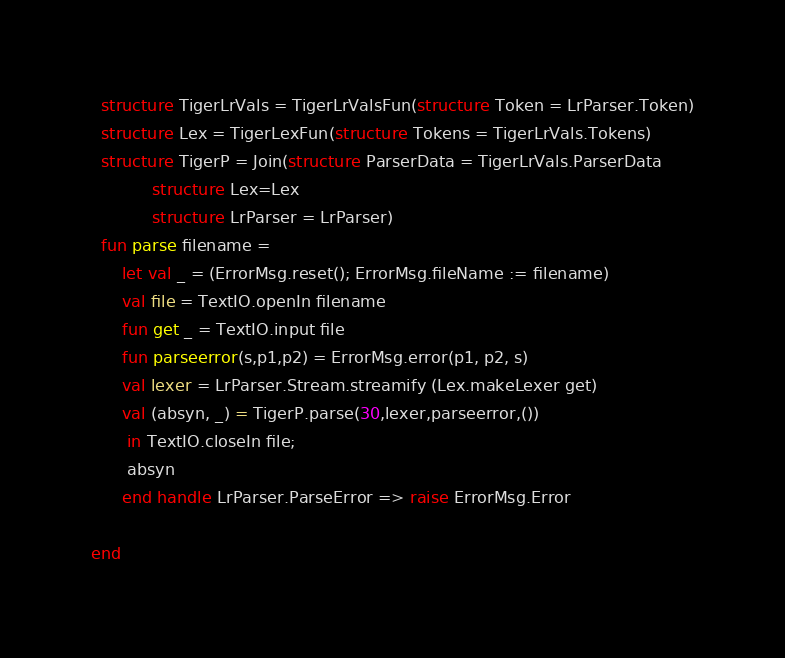Convert code to text. <code><loc_0><loc_0><loc_500><loc_500><_SML_>  structure TigerLrVals = TigerLrValsFun(structure Token = LrParser.Token)
  structure Lex = TigerLexFun(structure Tokens = TigerLrVals.Tokens)
  structure TigerP = Join(structure ParserData = TigerLrVals.ParserData
			structure Lex=Lex
			structure LrParser = LrParser)
  fun parse filename =
      let val _ = (ErrorMsg.reset(); ErrorMsg.fileName := filename)
	  val file = TextIO.openIn filename
	  fun get _ = TextIO.input file
	  fun parseerror(s,p1,p2) = ErrorMsg.error(p1, p2, s)
	  val lexer = LrParser.Stream.streamify (Lex.makeLexer get)
	  val (absyn, _) = TigerP.parse(30,lexer,parseerror,())
       in TextIO.closeIn file;
	   absyn
      end handle LrParser.ParseError => raise ErrorMsg.Error

end



</code> 